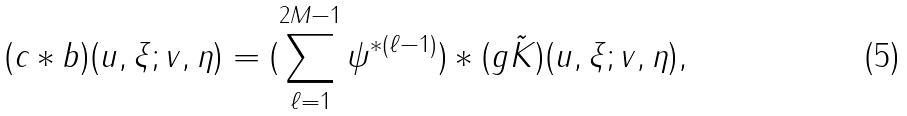Convert formula to latex. <formula><loc_0><loc_0><loc_500><loc_500>( c \ast b ) ( u , \xi ; v , \eta ) = ( \sum _ { \ell = 1 } ^ { 2 M - 1 } \psi ^ { \ast ( \ell - 1 ) } ) \ast ( g \tilde { K } ) ( u , \xi ; v , \eta ) ,</formula> 